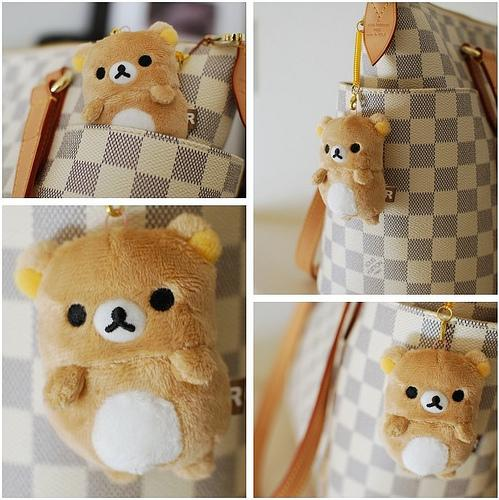Explain what the teddy bear is hanging from and specify the color and material of the hanging object. The teddy bear is hanging from a yellow strap made of rope or string, which is attached to the purse. Provide a brief description of the stuffed animal in the image and mention its color. A small brown teddy bear with yellow ears, a white belly, and black details on its nose is featured in the image. State two colors found on the bears' ears and mention the color of the bags' strap. The bear's ears are brown with yellow sections on the bottom, and the bag's strap is light brown. What is the predominant color of the stuffed animal and what feature on its face has black detail? The predominant color of the stuffed animal is light brown, and it has black detail on its nose. Describe the pattern and colors found on the purse and mention the color of the handle and chain link. The purse has a checkered design in gray and tan colors, with a brown handle and a gold-colored chain link. Describe the design and color of the purse in the image. The purse has a checkered pattern in gray and tan colors, featuring a brown leather strap and gold-colored chain link details. What is the overall color of the wall behind the purse and the bear, and state the type of pattern on the purse? The wall behind the purse and the bear is white in color, and the purse has a checkered pattern. Explain the position of the bear in relation to the purse and specify how it is attached. The teddy bear is hanging off the purse by a yellow strap and partially inside one of the purse's pockets, making it look like it is peeking out. Identify the type of bag and the position of the teddy bear in relation to the bag. The bag is a Louis Vuitton purse, and the teddy bear is hanging from the bag as well as being partially inside a pocket on the purse. What are the colors of the stuffed animal's abdomen and mention one animal feature beneath its head. The stuffed animal has a white circle on its abdomen, and its paws are beneath its head. 